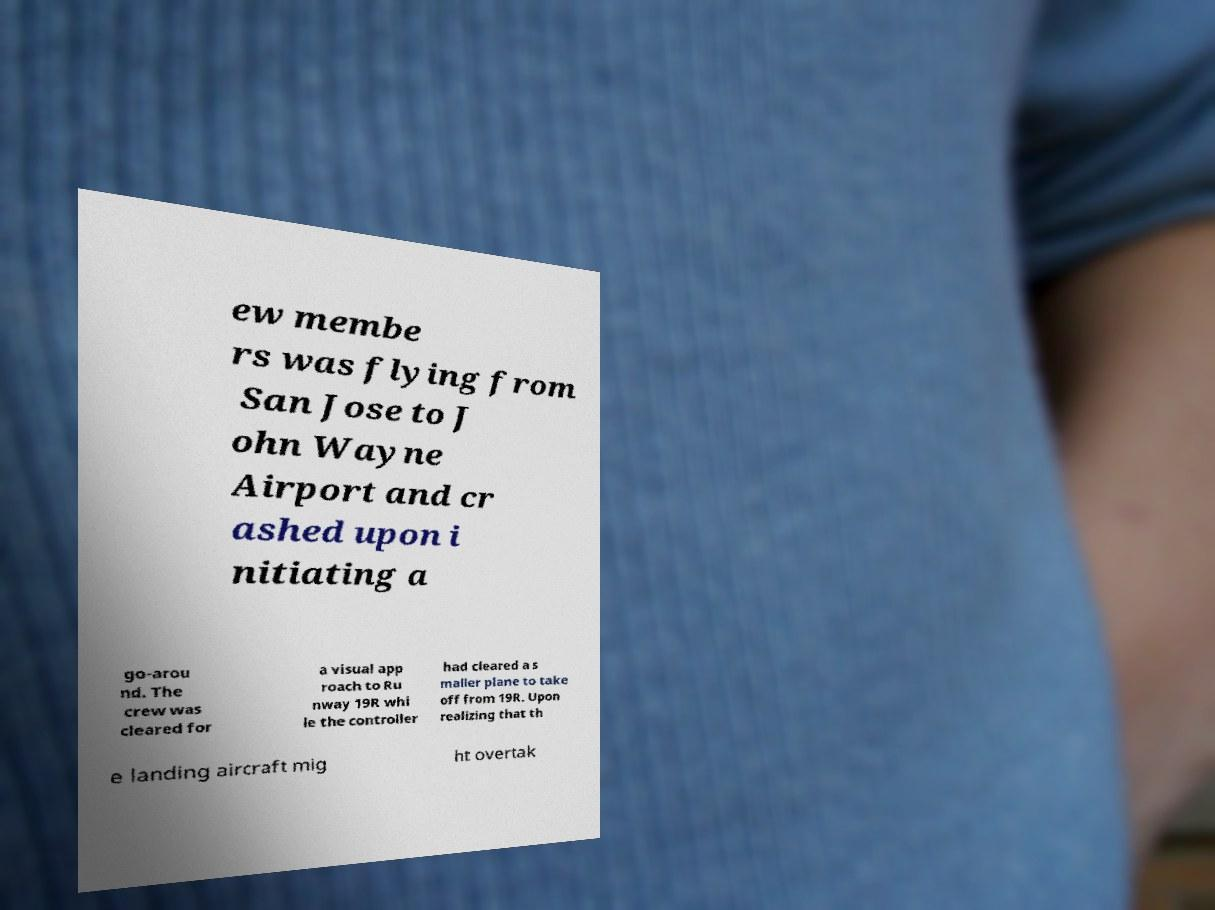Can you accurately transcribe the text from the provided image for me? ew membe rs was flying from San Jose to J ohn Wayne Airport and cr ashed upon i nitiating a go-arou nd. The crew was cleared for a visual app roach to Ru nway 19R whi le the controller had cleared a s maller plane to take off from 19R. Upon realizing that th e landing aircraft mig ht overtak 